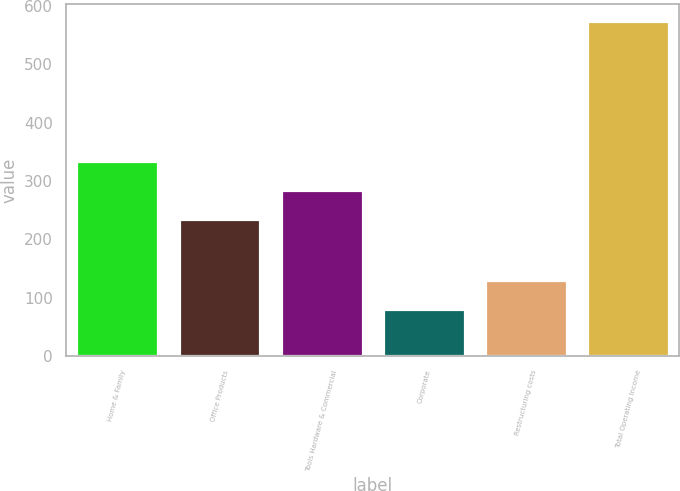Convert chart. <chart><loc_0><loc_0><loc_500><loc_500><bar_chart><fcel>Home & Family<fcel>Office Products<fcel>Tools Hardware & Commercial<fcel>Corporate<fcel>Restructuring costs<fcel>Total Operating Income<nl><fcel>334.06<fcel>235.2<fcel>284.63<fcel>80.6<fcel>130.03<fcel>574.9<nl></chart> 